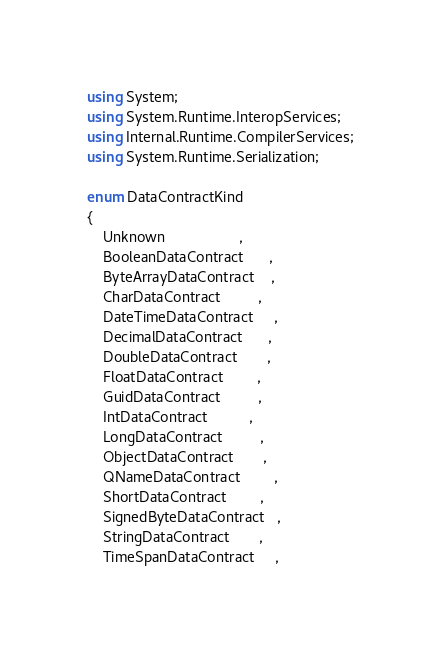<code> <loc_0><loc_0><loc_500><loc_500><_C#_>using System;
using System.Runtime.InteropServices;
using Internal.Runtime.CompilerServices;
using System.Runtime.Serialization;

enum DataContractKind
{
    Unknown                  ,
    BooleanDataContract      ,
    ByteArrayDataContract    ,
    CharDataContract         ,
    DateTimeDataContract     ,
    DecimalDataContract      ,
    DoubleDataContract       ,
    FloatDataContract        ,
    GuidDataContract         ,
    IntDataContract          ,
    LongDataContract         ,
    ObjectDataContract       ,
    QNameDataContract        ,
    ShortDataContract        ,
    SignedByteDataContract   ,
    StringDataContract       ,
    TimeSpanDataContract     ,</code> 